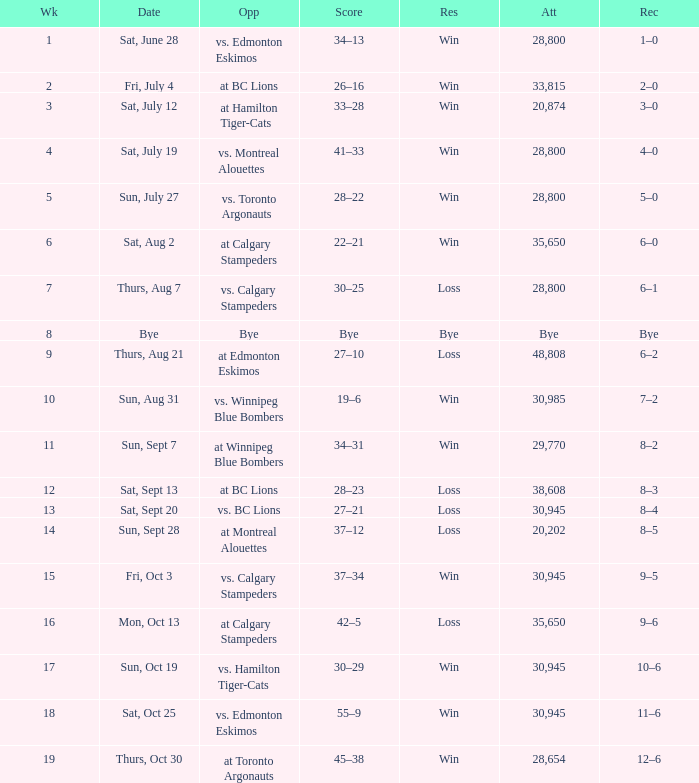What was the date of the game with an attendance of 20,874 fans? Sat, July 12. 